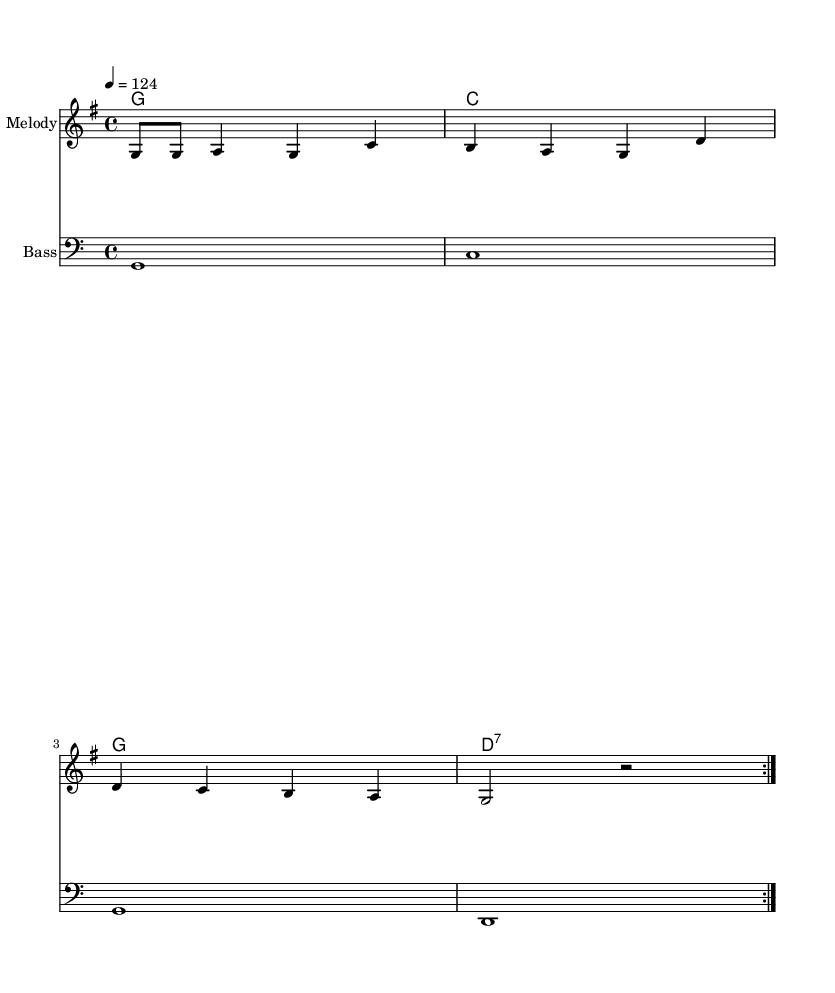What is the key signature of this music? The key signature is G major, which has one sharp (F#). This can be identified at the beginning of the staff where the key signature is indicated.
Answer: G major What is the time signature of this music? The time signature is 4/4, which means there are four beats in each measure and a quarter note gets one beat. It can be seen at the beginning of the score written as "4/4".
Answer: 4/4 What is the tempo marking for this piece? The tempo marking is 124 beats per minute. It is explicitly stated in the score, indicating how fast the piece should be played.
Answer: 124 How many times is the main melody repeated? The main melody is repeated twice, as indicated by the "repeat volta 2" marking in the sheet music. This shows that the melody section is meant to be played again.
Answer: 2 What type of music is this piece classified as? This piece is classified as Deep House, which is a subgenre of house music. The structure and rhythmic elements typical of house music suggest this classification, and it connects to the theme of baseball walk-up songs.
Answer: Deep House What chord is played after the second measure? The chord played after the second measure is D7, as indicated by the chord names written above the staff. This shows the harmonic progression following the melody.
Answer: D7 What is the bass clef used for? The bass clef is used to notate lower pitches, indicating that the notes written in this staff are intended for bass instruments or lower vocal ranges. Its presence is marked clearly at the beginning of the bass staff.
Answer: Lower pitches 